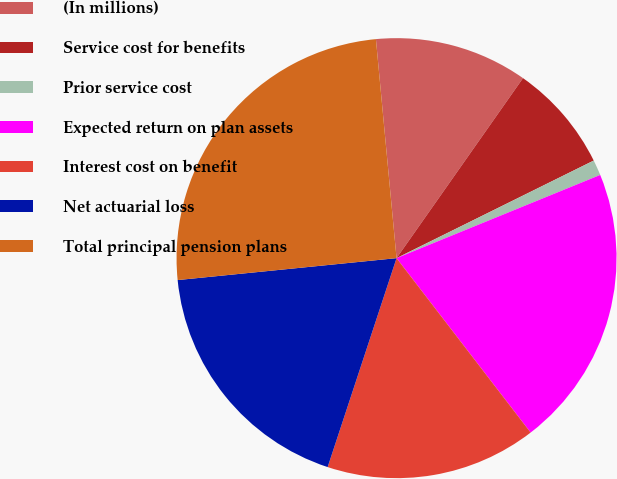Convert chart to OTSL. <chart><loc_0><loc_0><loc_500><loc_500><pie_chart><fcel>(In millions)<fcel>Service cost for benefits<fcel>Prior service cost<fcel>Expected return on plan assets<fcel>Interest cost on benefit<fcel>Net actuarial loss<fcel>Total principal pension plans<nl><fcel>11.24%<fcel>7.94%<fcel>1.14%<fcel>20.74%<fcel>15.5%<fcel>18.34%<fcel>25.09%<nl></chart> 